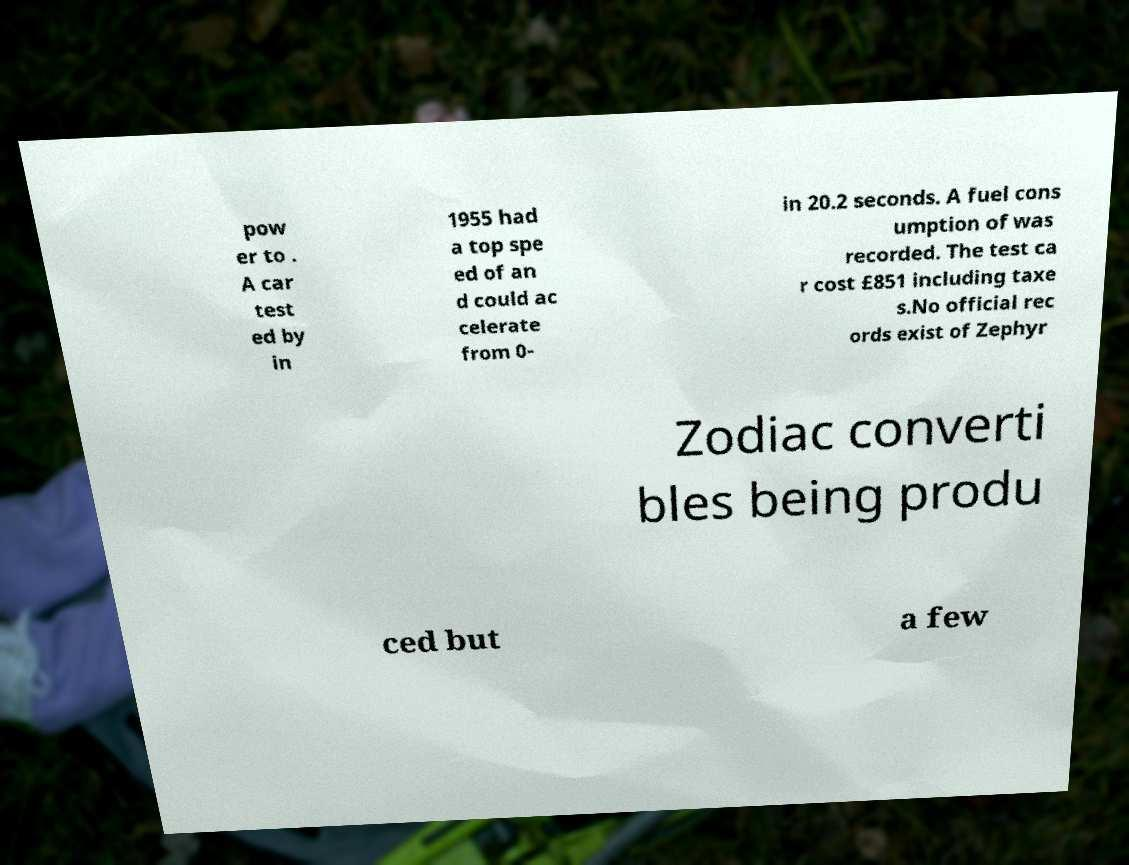What messages or text are displayed in this image? I need them in a readable, typed format. pow er to . A car test ed by in 1955 had a top spe ed of an d could ac celerate from 0- in 20.2 seconds. A fuel cons umption of was recorded. The test ca r cost £851 including taxe s.No official rec ords exist of Zephyr Zodiac converti bles being produ ced but a few 